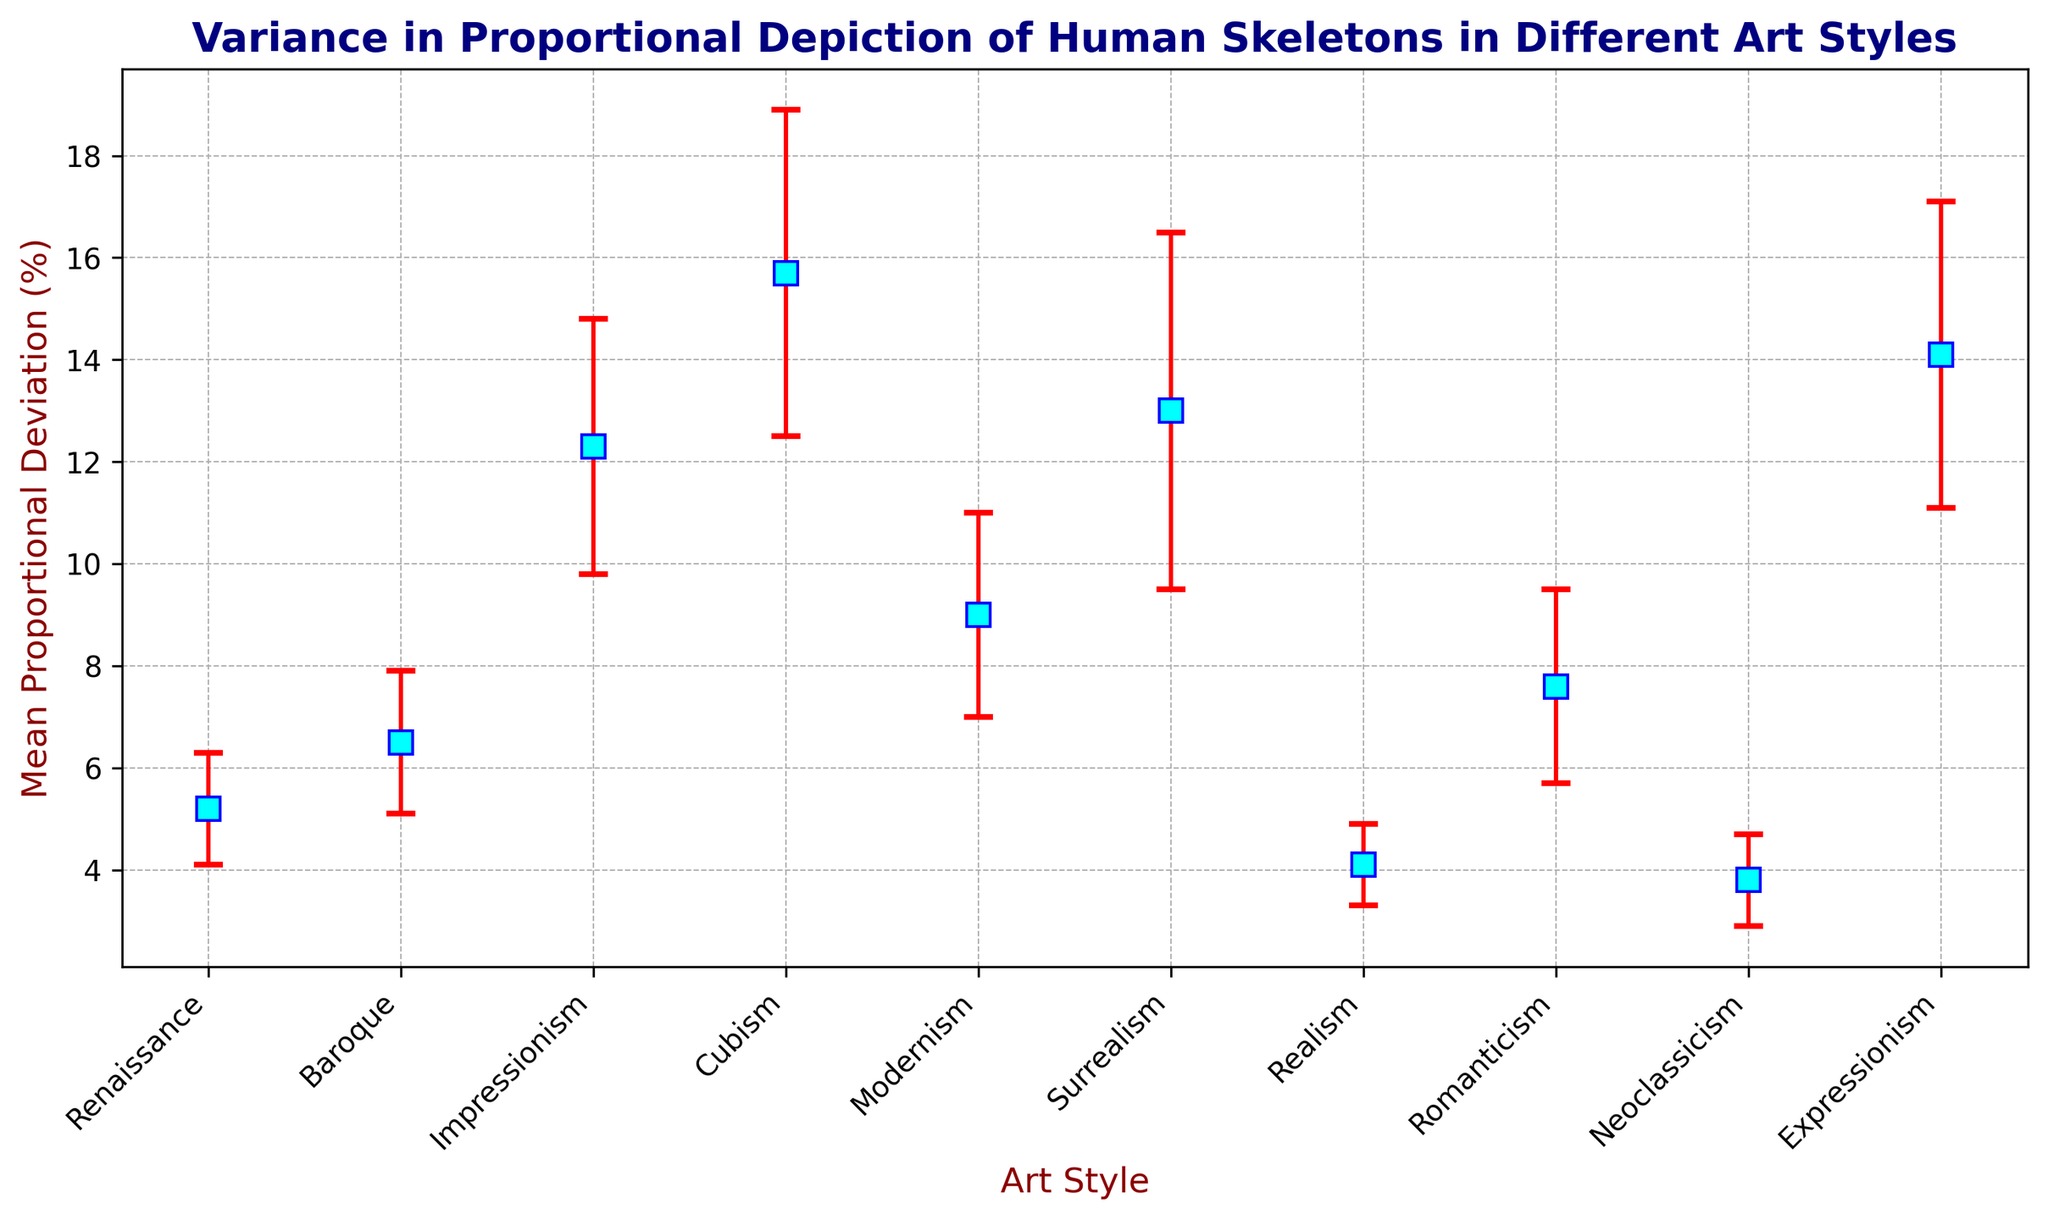Which art style has the highest mean proportional deviation? Look for the art style with the tallest marker. Cubism has the highest mean proportional deviation of 15.7%
Answer: Cubism Which art style has the lowest mean proportional deviation? Identify the art style with the shortest marker. Neoclassicism has the lowest mean proportional deviation of 3.8%
Answer: Neoclassicism What's the difference in mean proportional deviation between Realism and Surrealism? Realism has a mean of 4.1%, and Surrealism has a mean of 13.0%. The difference is 13.0% - 4.1%
Answer: 8.9% Which art styles have a mean proportional deviation greater than 10%? Identify all styles with markers taller than the 10% grid line. Impressionism (12.3%), Cubism (15.7%), Surrealism (13.0%), and Expressionism (14.1%) meet this criterion
Answer: Impressionism, Cubism, Surrealism, Expressionism What is the range of standard deviations across all art styles? The smallest standard deviation is 0.8 (Realism), and the largest is 3.5 (Surrealism). The range is 3.5 - 0.8
Answer: 2.7 Compare the accuracy of Renaissance and Romanticism art styles. Which one is more accurate? Renaissance has a mean deviation of 5.2% while Romanticism has 7.6%. Lower deviation indicates higher accuracy, so Renaissance is more accurate
Answer: Renaissance What’s the mean proportional deviation of art styles with the sample size of exactly 10? Renaissance (5.2%), Cubism (15.7%), Neoclassicism (3.8%). The mean is (5.2 + 15.7 + 3.8) / 3
Answer: 8.23% Which art style shows the largest variability in proportional depiction? Identify the style with the largest error bar. Surrealism has the largest standard deviation of 3.5%, indicating the largest variability
Answer: Surrealism Calculate the average mean proportional deviation of Baroque and Romanticism art styles. Baroque's mean is 6.5%, and Romanticism's mean is 7.6%. The average is (6.5% + 7.6%) / 2
Answer: 7.05% How many art styles have a mean proportional deviation within 1% of the Renaissance art style? Renaissance’s mean is 5.2% (4.2% to 6.2%). Only Baroque (6.5%) is within this range
Answer: 1 